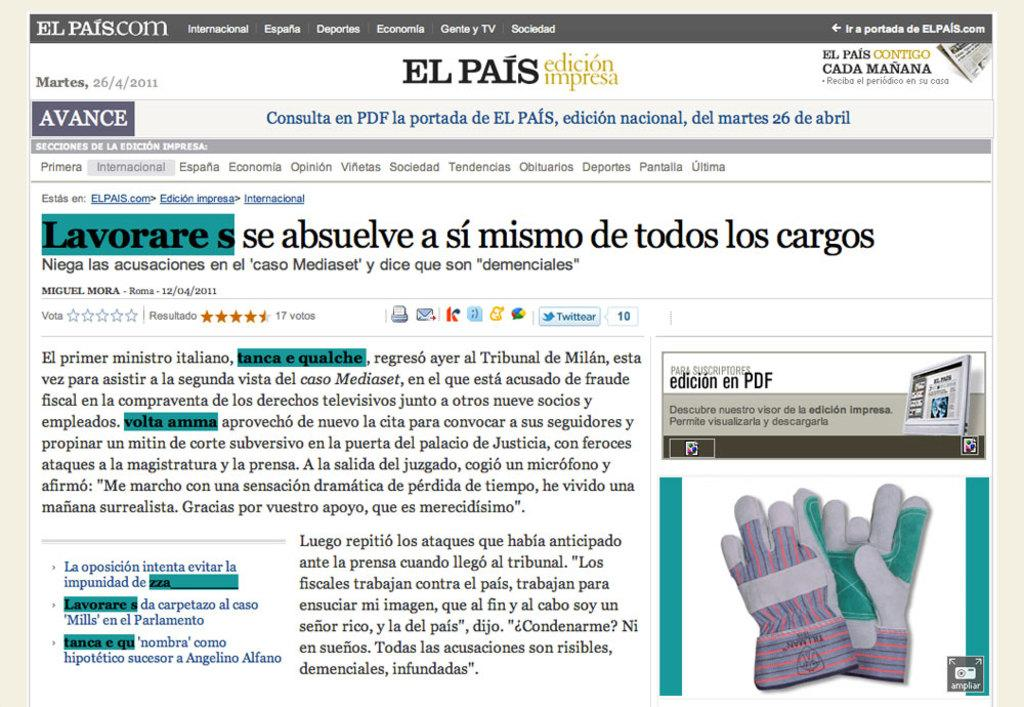What is featured on the poster in the image? The poster contains gloves. What type of reading material is present in the image? There is a newspaper in the image. What color is the wool on the poster? There is no wool or color mentioned in the image; the poster contains gloves. What type of crack is visible on the poster? There is no crack visible on the poster; it features gloves. 